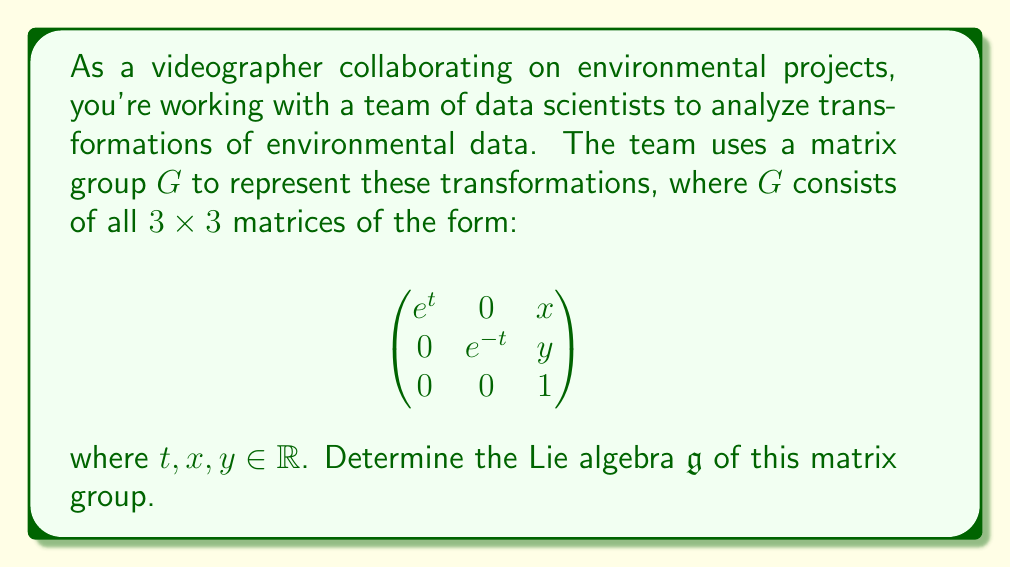What is the answer to this math problem? To find the Lie algebra $\mathfrak{g}$ of the matrix group $G$, we need to follow these steps:

1) The Lie algebra consists of the tangent space at the identity element of the group. We can find this by considering a curve $\gamma(s)$ in $G$ that passes through the identity at $s = 0$.

2) Let's parametrize a general element of the group as:

   $$A(s) = \begin{pmatrix}
   e^{t(s)} & 0 & x(s) \\
   0 & e^{-t(s)} & y(s) \\
   0 & 0 & 1
   \end{pmatrix}$$

   where $t(0) = 0$, $x(0) = 0$, and $y(0) = 0$ to ensure $A(0)$ is the identity matrix.

3) The elements of the Lie algebra are obtained by differentiating $A(s)$ at $s = 0$:

   $$\frac{d}{ds}A(s)\bigg|_{s=0} = \begin{pmatrix}
   t'(0)e^{t(0)} & 0 & x'(0) \\
   0 & -t'(0)e^{-t(0)} & y'(0) \\
   0 & 0 & 0
   \end{pmatrix} = \begin{pmatrix}
   t'(0) & 0 & x'(0) \\
   0 & -t'(0) & y'(0) \\
   0 & 0 & 0
   \end{pmatrix}$$

4) We can represent any element of the Lie algebra as a linear combination of three basis elements:

   $$X = \begin{pmatrix}
   1 & 0 & 0 \\
   0 & -1 & 0 \\
   0 & 0 & 0
   \end{pmatrix}, \quad
   Y = \begin{pmatrix}
   0 & 0 & 1 \\
   0 & 0 & 0 \\
   0 & 0 & 0
   \end{pmatrix}, \quad
   Z = \begin{pmatrix}
   0 & 0 & 0 \\
   0 & 0 & 1 \\
   0 & 0 & 0
   \end{pmatrix}$$

5) Therefore, any element of the Lie algebra $\mathfrak{g}$ can be written as $aX + bY + cZ$ where $a, b, c \in \mathbb{R}$.

6) To complete the description of the Lie algebra, we need to compute the Lie brackets of these basis elements:

   $[X,Y] = XY - YX = Y$
   $[X,Z] = XZ - ZX = -Z$
   $[Y,Z] = YZ - ZY = 0$

These relations fully characterize the Lie algebra $\mathfrak{g}$.
Answer: The Lie algebra $\mathfrak{g}$ of the given matrix group consists of all matrices of the form:

$$\begin{pmatrix}
a & 0 & b \\
0 & -a & c \\
0 & 0 & 0
\end{pmatrix}$$

where $a, b, c \in \mathbb{R}$. It is a 3-dimensional Lie algebra with basis elements $X, Y, Z$ satisfying the Lie bracket relations:

$[X,Y] = Y$, $[X,Z] = -Z$, $[Y,Z] = 0$ 